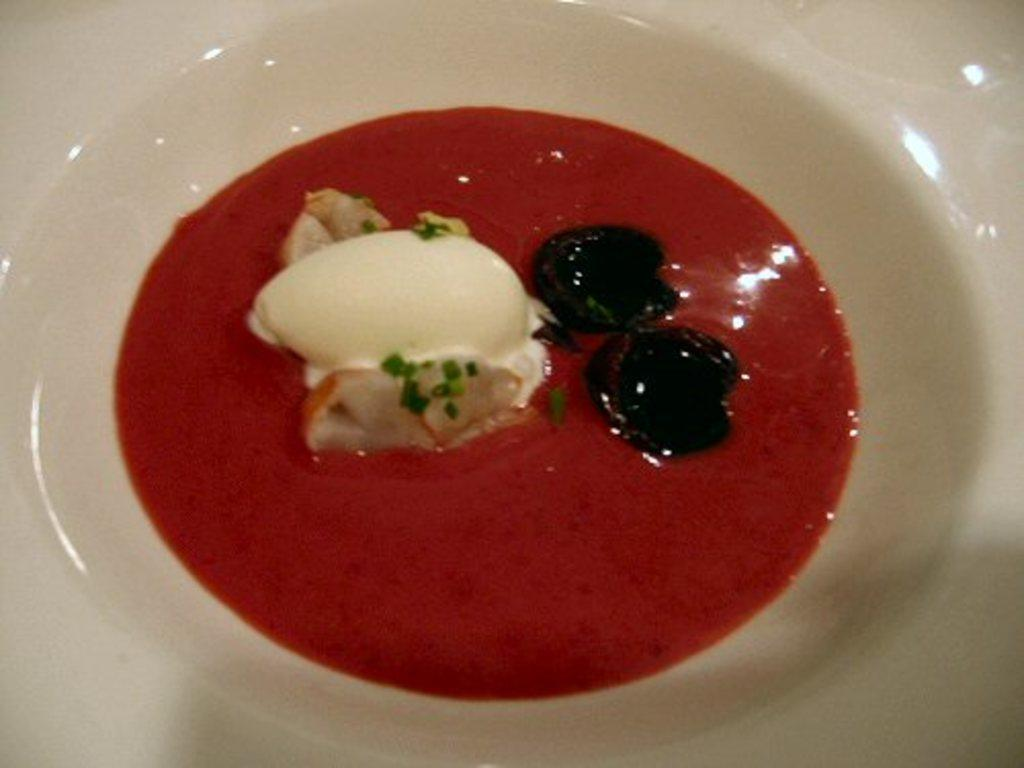What is located in the center of the image? There is a plate in the center of the image. What is on the plate? There is a food item on the plate. What type of doctor is examining the food item on the plate? There is no doctor present in the image, and the food item is not being examined by anyone. 